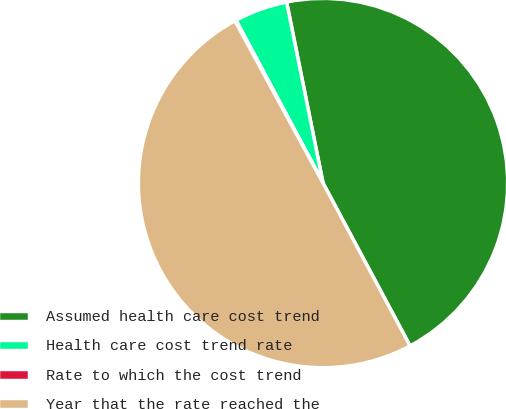Convert chart to OTSL. <chart><loc_0><loc_0><loc_500><loc_500><pie_chart><fcel>Assumed health care cost trend<fcel>Health care cost trend rate<fcel>Rate to which the cost trend<fcel>Year that the rate reached the<nl><fcel>45.35%<fcel>4.65%<fcel>0.11%<fcel>49.89%<nl></chart> 